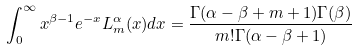Convert formula to latex. <formula><loc_0><loc_0><loc_500><loc_500>\int _ { 0 } ^ { \infty } x ^ { \beta - 1 } e ^ { - x } L _ { m } ^ { \alpha } ( x ) d x = \frac { \Gamma ( \alpha - \beta + m + 1 ) \Gamma ( \beta ) } { m ! \Gamma ( \alpha - \beta + 1 ) }</formula> 